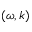Convert formula to latex. <formula><loc_0><loc_0><loc_500><loc_500>( \omega , k )</formula> 